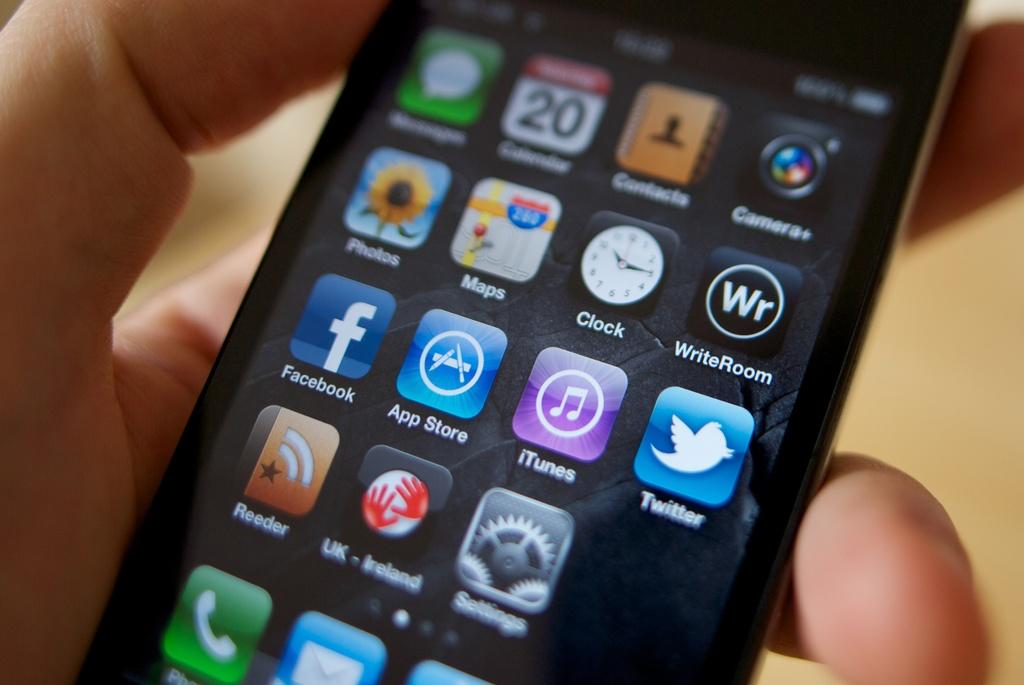What is the name of the app with a sunflower?
Offer a very short reply. Photos. 